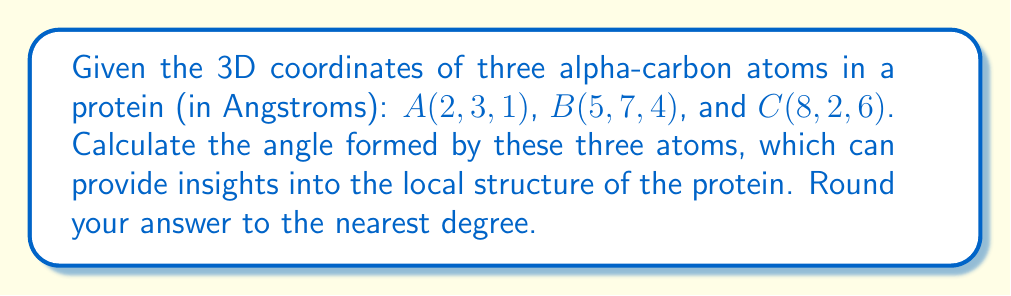Solve this math problem. To find the angle formed by three points in 3D space, we can use vector operations:

1. Calculate vectors $\vec{BA}$ and $\vec{BC}$:
   $\vec{BA} = A - B = (2-5, 3-7, 1-4) = (-3, -4, -3)$
   $\vec{BC} = C - B = (8-5, 2-7, 6-4) = (3, -5, 2)$

2. Use the dot product formula to find the angle $\theta$:
   $$\cos \theta = \frac{\vec{BA} \cdot \vec{BC}}{|\vec{BA}||\vec{BC}|}$$

3. Calculate the dot product $\vec{BA} \cdot \vec{BC}$:
   $(-3)(3) + (-4)(-5) + (-3)(2) = -9 + 20 - 6 = 5$

4. Calculate the magnitudes:
   $|\vec{BA}| = \sqrt{(-3)^2 + (-4)^2 + (-3)^2} = \sqrt{34}$
   $|\vec{BC}| = \sqrt{3^2 + (-5)^2 + 2^2} = \sqrt{38}$

5. Substitute into the formula:
   $$\cos \theta = \frac{5}{\sqrt{34}\sqrt{38}}$$

6. Take the inverse cosine (arccos) of both sides:
   $$\theta = \arccos\left(\frac{5}{\sqrt{34}\sqrt{38}}\right)$$

7. Calculate and round to the nearest degree:
   $\theta \approx 88°$
Answer: 88° 